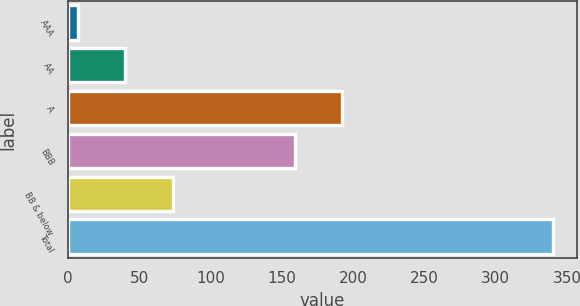<chart> <loc_0><loc_0><loc_500><loc_500><bar_chart><fcel>AAA<fcel>AA<fcel>A<fcel>BBB<fcel>BB & below<fcel>Total<nl><fcel>7<fcel>40.3<fcel>192.3<fcel>159<fcel>73.6<fcel>340<nl></chart> 